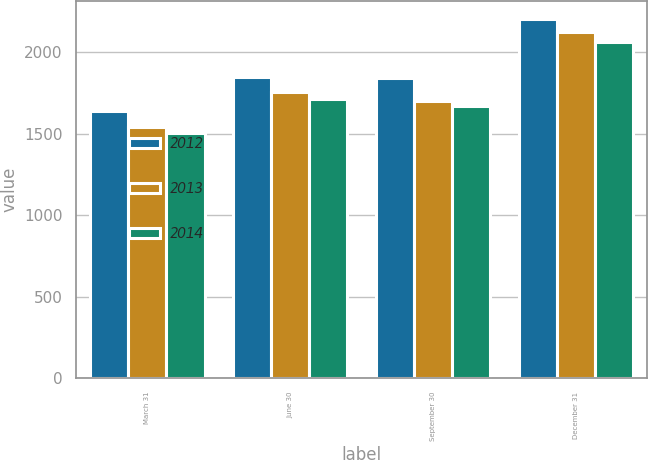Convert chart to OTSL. <chart><loc_0><loc_0><loc_500><loc_500><stacked_bar_chart><ecel><fcel>March 31<fcel>June 30<fcel>September 30<fcel>December 31<nl><fcel>2012<fcel>1637.5<fcel>1851.4<fcel>1841.1<fcel>2207.1<nl><fcel>2013<fcel>1543<fcel>1756.2<fcel>1700.4<fcel>2122.7<nl><fcel>2014<fcel>1506.8<fcel>1715.7<fcel>1670.4<fcel>2063.3<nl></chart> 